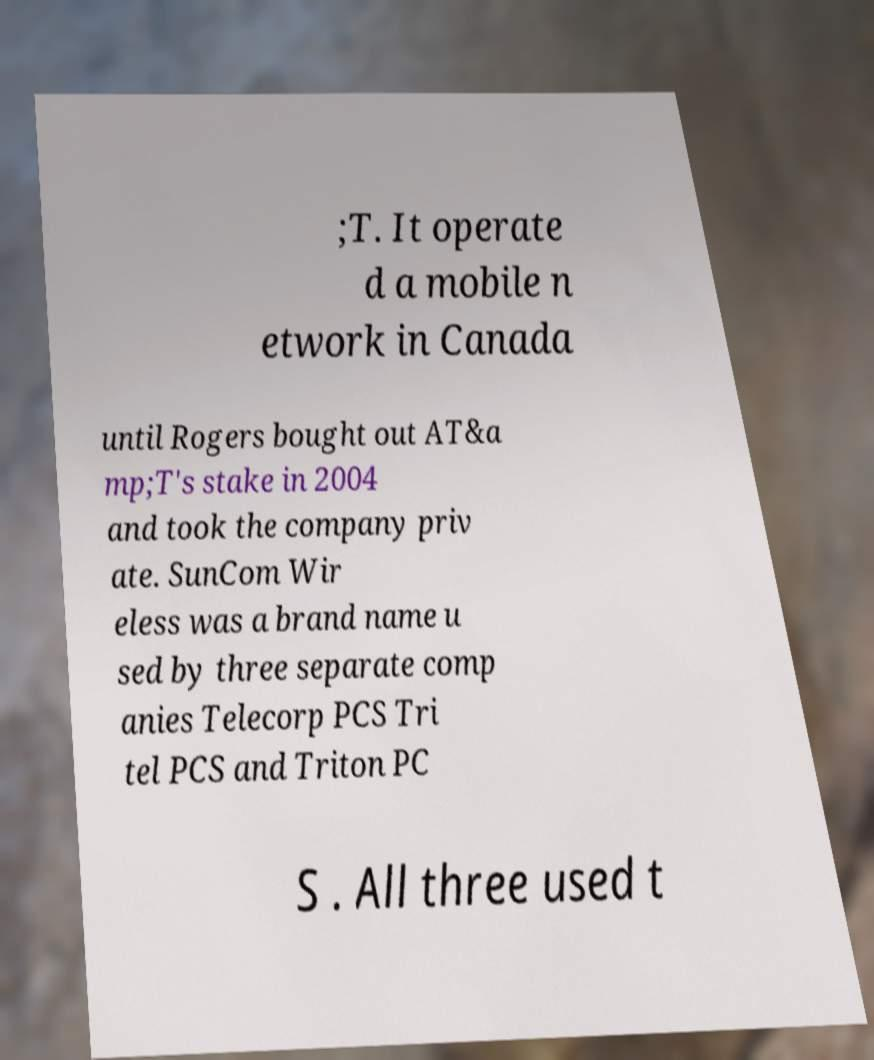For documentation purposes, I need the text within this image transcribed. Could you provide that? ;T. It operate d a mobile n etwork in Canada until Rogers bought out AT&a mp;T's stake in 2004 and took the company priv ate. SunCom Wir eless was a brand name u sed by three separate comp anies Telecorp PCS Tri tel PCS and Triton PC S . All three used t 